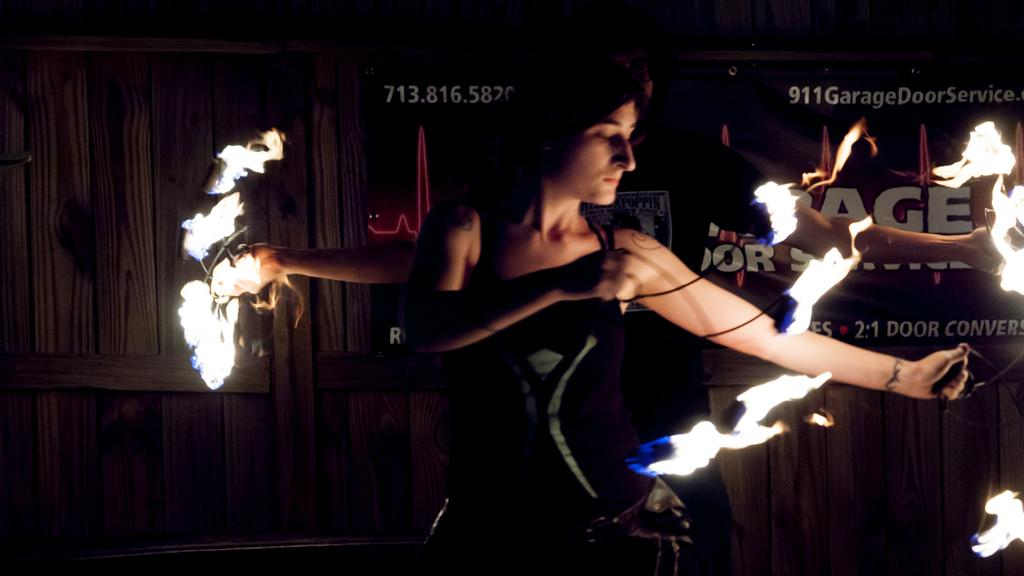What is the main subject of the image? The main subject of the image is a person standing. What is the person doing in the image? The person is playing with fire. How does the person compare to the road in the image? There is no road present in the image, so it is not possible to make a comparison. How does the person feel after taking a rest in the image? There is no indication of the person taking a rest in the image, so it is not possible to determine how they might feel after doing so. 